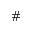<formula> <loc_0><loc_0><loc_500><loc_500>\#</formula> 